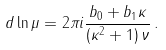Convert formula to latex. <formula><loc_0><loc_0><loc_500><loc_500>d \ln \mu = 2 \pi i \frac { b _ { 0 } + b _ { 1 } \kappa } { ( \kappa ^ { 2 } + 1 ) \, \nu } \, .</formula> 